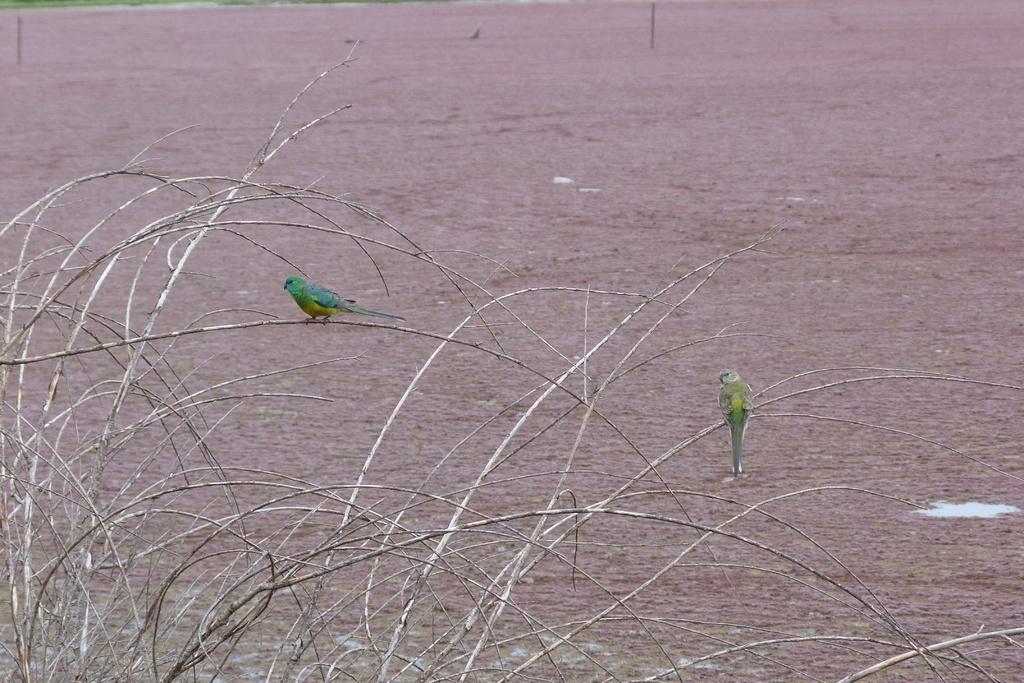Could you give a brief overview of what you see in this image? In the image in the center we can see two green color birds on the branch. In the background we can see grass and ground. 